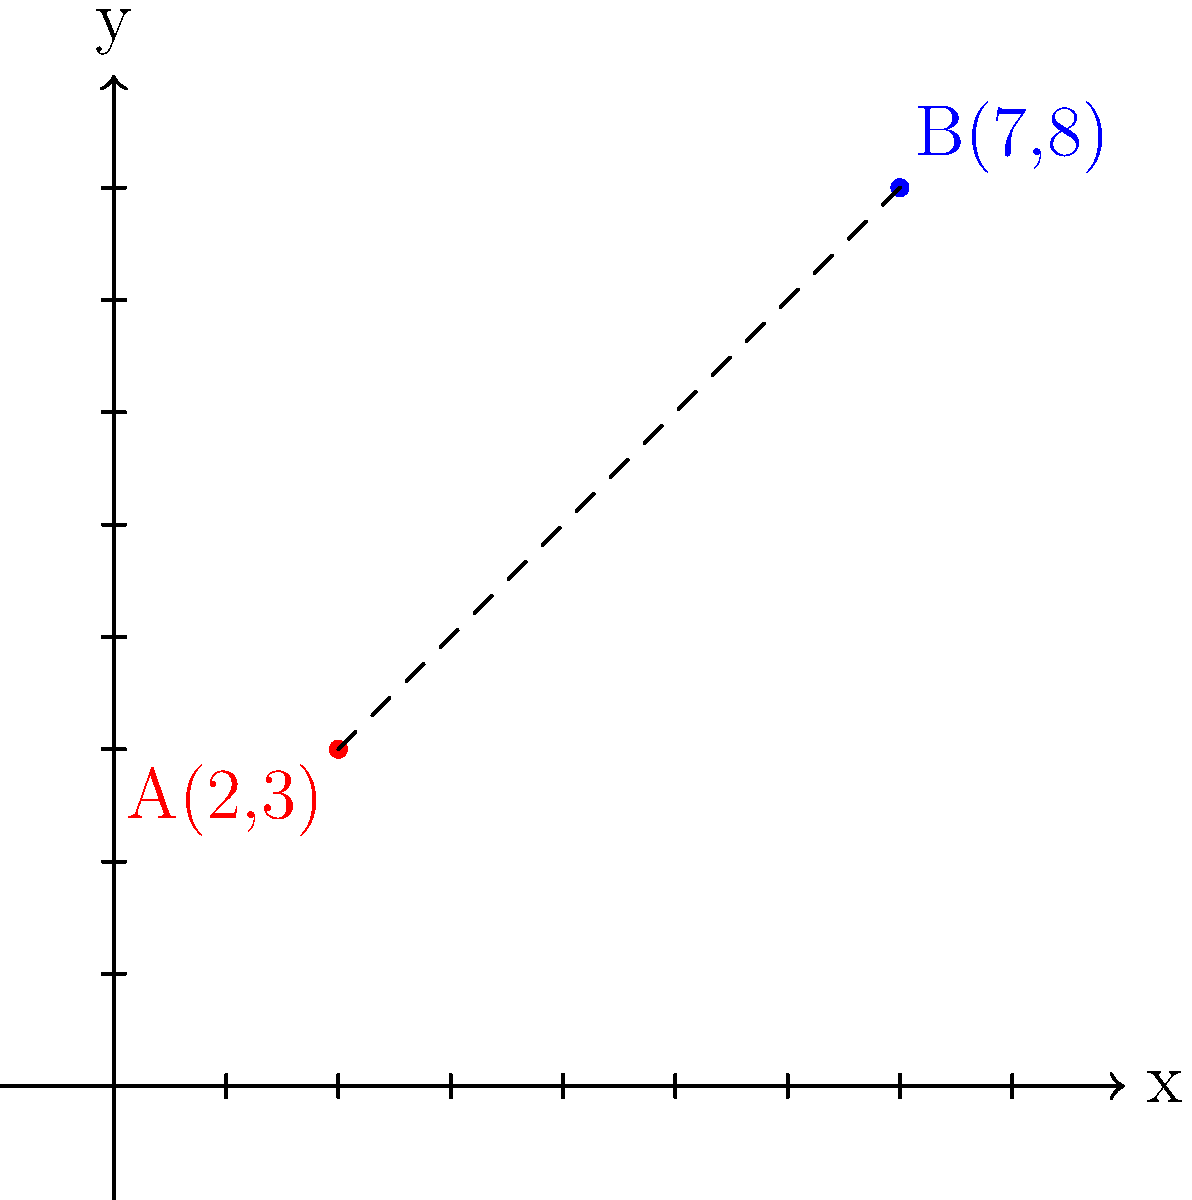As you're helping your new immigrant friend navigate the school's social landscape, you decide to use a coordinate plane to visualize the "social distance" between different groups. If point A(2,3) represents your friend's current social circle and point B(7,8) represents a group you want to introduce them to, what is the shortest "social distance" between these two points? Round your answer to two decimal places. To find the distance between two points on a coordinate plane, we can use the distance formula:

$$ d = \sqrt{(x_2 - x_1)^2 + (y_2 - y_1)^2} $$

Where $(x_1, y_1)$ are the coordinates of the first point and $(x_2, y_2)$ are the coordinates of the second point.

Let's plug in our values:
Point A: $(x_1, y_1) = (2, 3)$
Point B: $(x_2, y_2) = (7, 8)$

Now, let's calculate:

1) First, find the differences:
   $x_2 - x_1 = 7 - 2 = 5$
   $y_2 - y_1 = 8 - 3 = 5$

2) Square these differences:
   $(x_2 - x_1)^2 = 5^2 = 25$
   $(y_2 - y_1)^2 = 5^2 = 25$

3) Add these squared differences:
   $25 + 25 = 50$

4) Take the square root:
   $d = \sqrt{50}$

5) Simplify:
   $d = 5\sqrt{2} \approx 7.07$

6) Round to two decimal places:
   $d \approx 7.07$

Therefore, the shortest "social distance" between the two points is approximately 7.07 units.
Answer: 7.07 